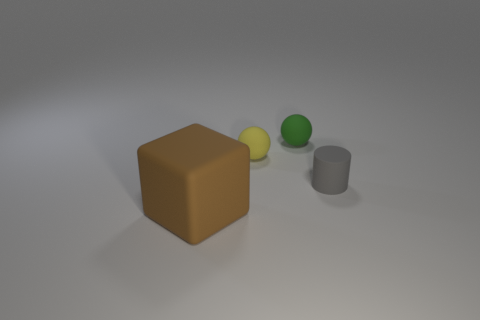Do the gray cylinder and the yellow rubber object have the same size?
Provide a succinct answer. Yes. Are there any blue spheres?
Offer a terse response. No. What is the size of the gray rubber cylinder on the right side of the rubber ball that is behind the tiny rubber sphere that is to the left of the green rubber thing?
Offer a terse response. Small. How many tiny blue cylinders are made of the same material as the big brown object?
Your response must be concise. 0. What number of green rubber spheres are the same size as the yellow sphere?
Ensure brevity in your answer.  1. The object that is to the right of the sphere that is to the right of the small ball left of the small green matte sphere is made of what material?
Provide a succinct answer. Rubber. What number of objects are gray cylinders or spheres?
Your response must be concise. 3. Is there anything else that is the same material as the gray object?
Provide a short and direct response. Yes. What is the shape of the large matte thing?
Provide a succinct answer. Cube. What shape is the object that is in front of the object that is right of the tiny green matte thing?
Your response must be concise. Cube. 